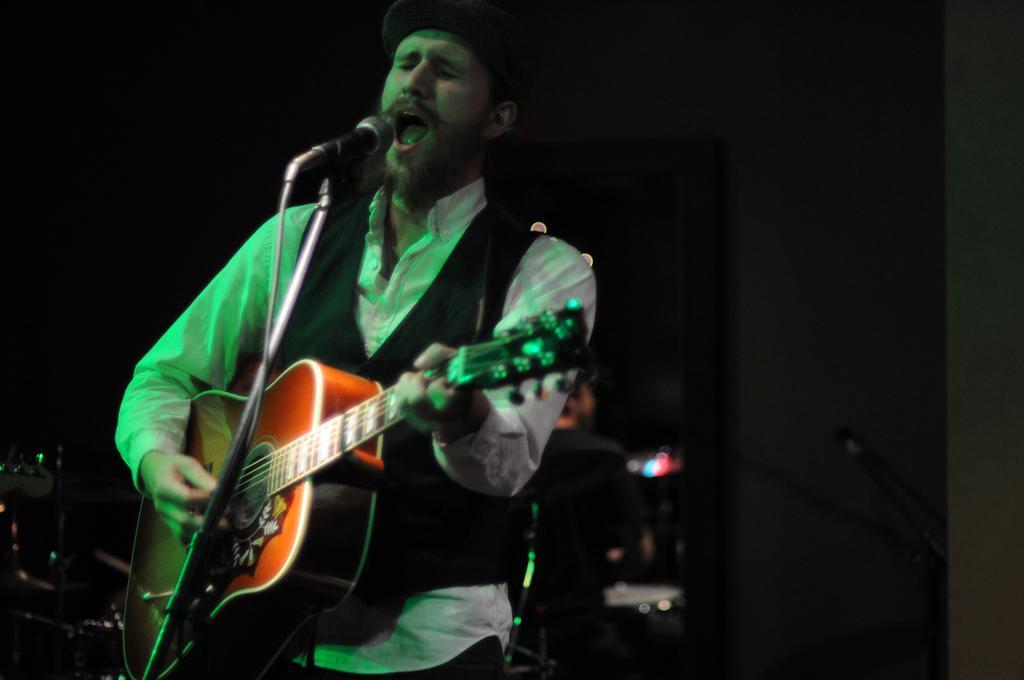Please provide a concise description of this image. In this picture we can see a man who is singing on the mike and he is playing a guitar. 